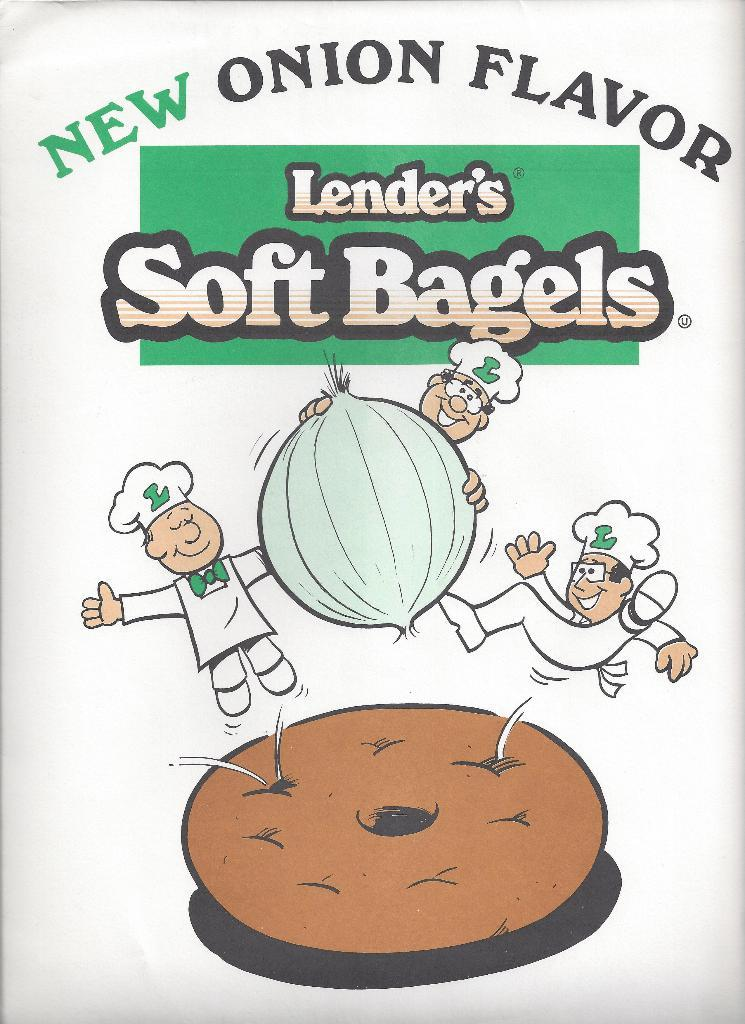What is the main subject of the poster in the image? The poster contains images of people and objects. What else can be seen on the poster besides the images? There is text printed on the poster. What type of pain is depicted in the poster? There is no depiction of pain in the poster; it contains images of people and objects, along with text. 